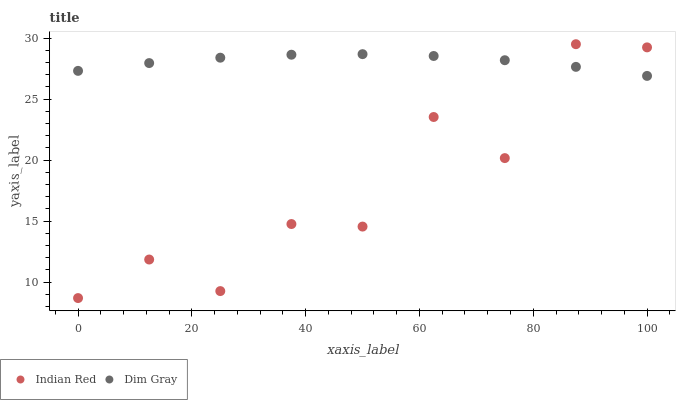Does Indian Red have the minimum area under the curve?
Answer yes or no. Yes. Does Dim Gray have the maximum area under the curve?
Answer yes or no. Yes. Does Indian Red have the maximum area under the curve?
Answer yes or no. No. Is Dim Gray the smoothest?
Answer yes or no. Yes. Is Indian Red the roughest?
Answer yes or no. Yes. Is Indian Red the smoothest?
Answer yes or no. No. Does Indian Red have the lowest value?
Answer yes or no. Yes. Does Indian Red have the highest value?
Answer yes or no. Yes. Does Dim Gray intersect Indian Red?
Answer yes or no. Yes. Is Dim Gray less than Indian Red?
Answer yes or no. No. Is Dim Gray greater than Indian Red?
Answer yes or no. No. 